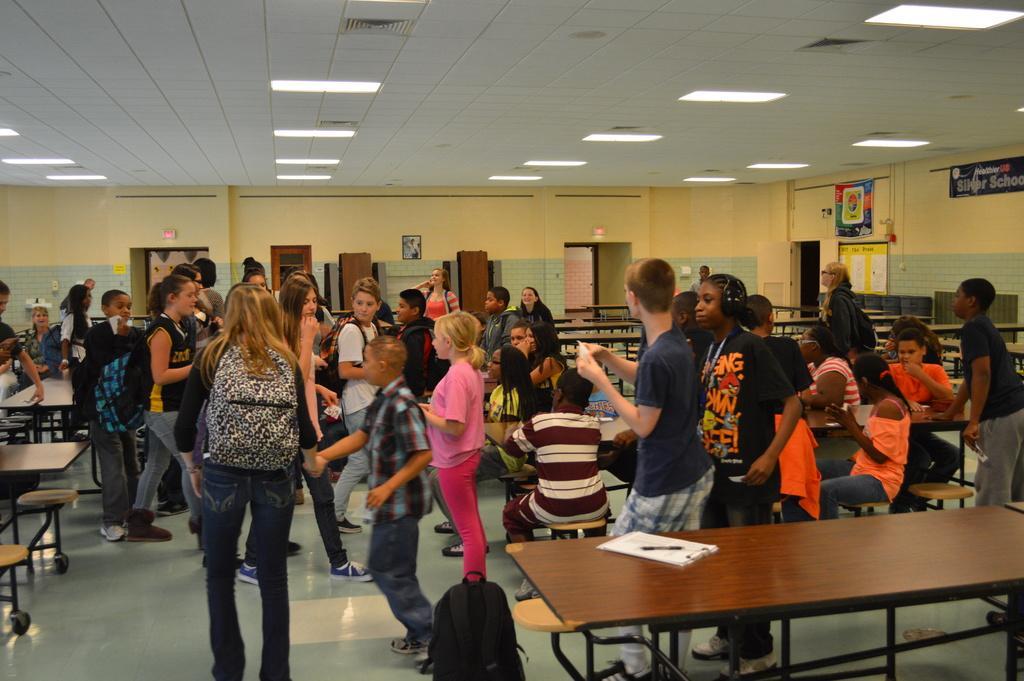Can you describe this image briefly? There is a group of people in the class. This girl is wearing a pink color T-Shirt and pant. This boy is wearing a shirt and pant. There is a pen and papers on the table. In the background, there is a wall. This is a signboard. And these people are standing on the floor. 